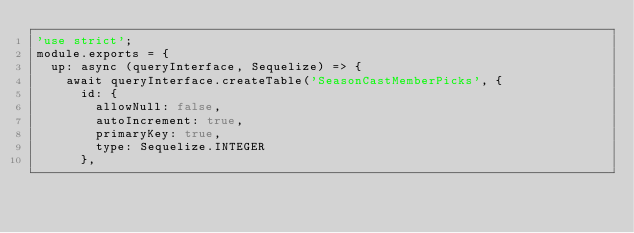Convert code to text. <code><loc_0><loc_0><loc_500><loc_500><_JavaScript_>'use strict';
module.exports = {
  up: async (queryInterface, Sequelize) => {
    await queryInterface.createTable('SeasonCastMemberPicks', {
      id: {
        allowNull: false,
        autoIncrement: true,
        primaryKey: true,
        type: Sequelize.INTEGER
      },</code> 